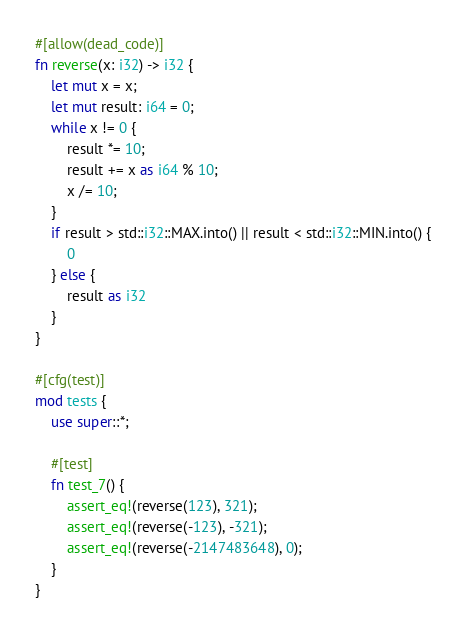Convert code to text. <code><loc_0><loc_0><loc_500><loc_500><_Rust_>#[allow(dead_code)]
fn reverse(x: i32) -> i32 {
    let mut x = x;
    let mut result: i64 = 0;
    while x != 0 {
        result *= 10;
        result += x as i64 % 10;
        x /= 10;
    }
    if result > std::i32::MAX.into() || result < std::i32::MIN.into() {
        0
    } else {
        result as i32
    }
}

#[cfg(test)]
mod tests {
    use super::*;

    #[test]
    fn test_7() {
        assert_eq!(reverse(123), 321);
        assert_eq!(reverse(-123), -321);
        assert_eq!(reverse(-2147483648), 0);
    }
}
</code> 